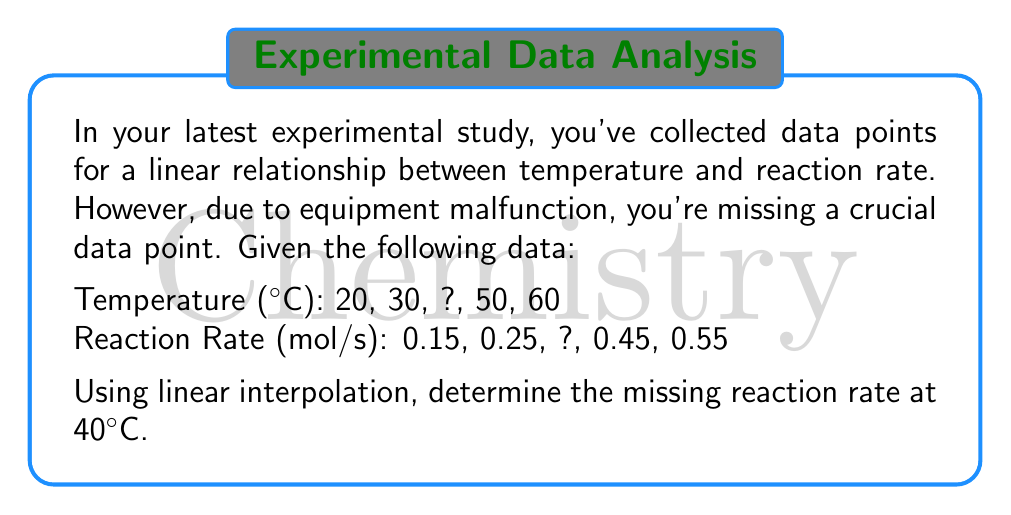Give your solution to this math problem. To solve this problem, we'll use linear interpolation. The steps are as follows:

1) First, we need to confirm that the relationship is indeed linear. We can do this by calculating the slope between each pair of known points:

   $$ \text{Slope} = \frac{\text{Change in Reaction Rate}}{\text{Change in Temperature}} $$

   Between 20°C and 30°C: $\frac{0.25 - 0.15}{30 - 20} = 0.01$ mol/s/°C
   Between 50°C and 60°C: $\frac{0.55 - 0.45}{60 - 50} = 0.01$ mol/s/°C

   The slopes are consistent, confirming a linear relationship.

2) Now, we can use linear interpolation to find the missing reaction rate at 40°C. We'll use the data points immediately before and after 40°C:

   Before: (30°C, 0.25 mol/s)
   After: (50°C, 0.45 mol/s)

3) The formula for linear interpolation is:

   $$ y = y_1 + \frac{(x - x_1)(y_2 - y_1)}{(x_2 - x_1)} $$

   Where:
   $x$ is the input value (40°C in this case)
   $(x_1, y_1)$ is the point before (30°C, 0.25 mol/s)
   $(x_2, y_2)$ is the point after (50°C, 0.45 mol/s)

4) Plugging in the values:

   $$ y = 0.25 + \frac{(40 - 30)(0.45 - 0.25)}{(50 - 30)} $$

5) Simplifying:

   $$ y = 0.25 + \frac{10 \cdot 0.20}{20} = 0.25 + 0.10 = 0.35 $$

Therefore, the interpolated reaction rate at 40°C is 0.35 mol/s.
Answer: 0.35 mol/s 